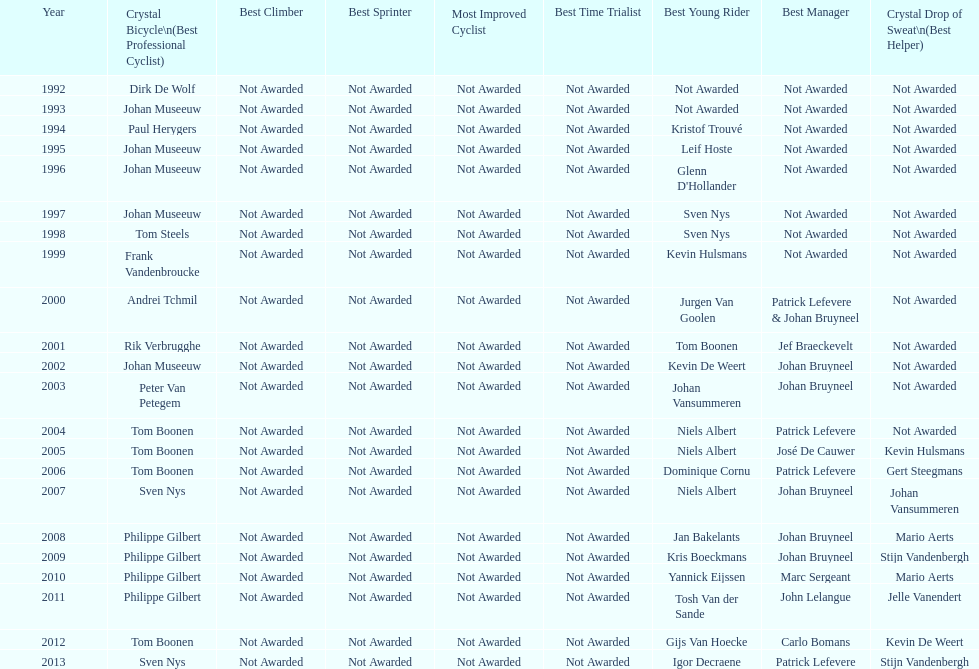What is the average number of times johan museeuw starred? 5. 